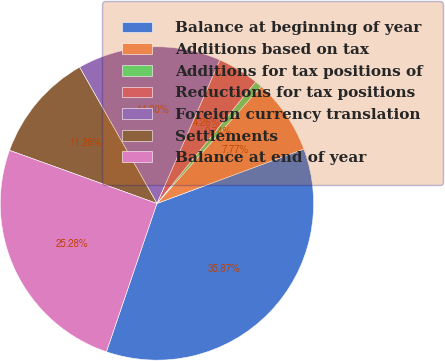Convert chart to OTSL. <chart><loc_0><loc_0><loc_500><loc_500><pie_chart><fcel>Balance at beginning of year<fcel>Additions based on tax<fcel>Additions for tax positions of<fcel>Reductions for tax positions<fcel>Foreign currency translation<fcel>Settlements<fcel>Balance at end of year<nl><fcel>35.87%<fcel>7.77%<fcel>0.74%<fcel>4.26%<fcel>14.8%<fcel>11.28%<fcel>25.28%<nl></chart> 